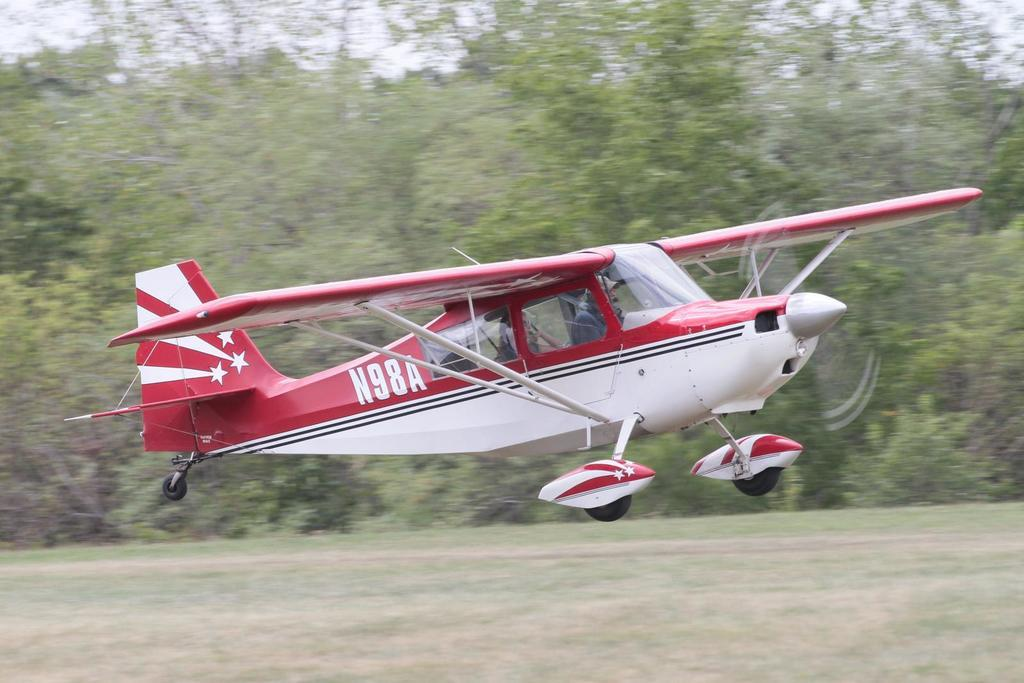What is the main subject of the image? The main subject of the image is an airplane. Is there any text visible on the airplane? Yes, there is text written on the airplane. What can be seen in the background of the image? There are trees in the background of the image. What type of basin is visible in the image? There is no basin present in the image; it features an airplane with text and trees in the background. Can you hear any noise coming from the airplane in the image? The image is silent, so it is not possible to hear any noise coming from the airplane. 